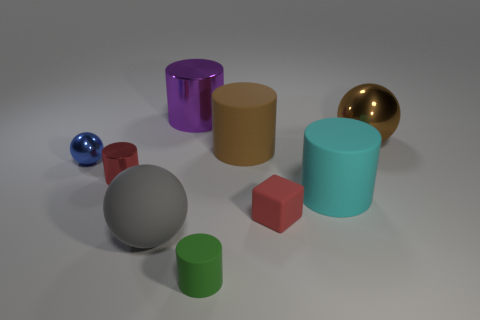Add 1 big gray objects. How many objects exist? 10 Subtract all metallic spheres. How many spheres are left? 1 Subtract all purple cylinders. How many cylinders are left? 4 Subtract all red cylinders. Subtract all green balls. How many cylinders are left? 4 Subtract all yellow blocks. How many blue spheres are left? 1 Subtract all small green rubber things. Subtract all green cylinders. How many objects are left? 7 Add 3 blue metal things. How many blue metal things are left? 4 Add 1 tiny gray spheres. How many tiny gray spheres exist? 1 Subtract 0 gray cylinders. How many objects are left? 9 Subtract all balls. How many objects are left? 6 